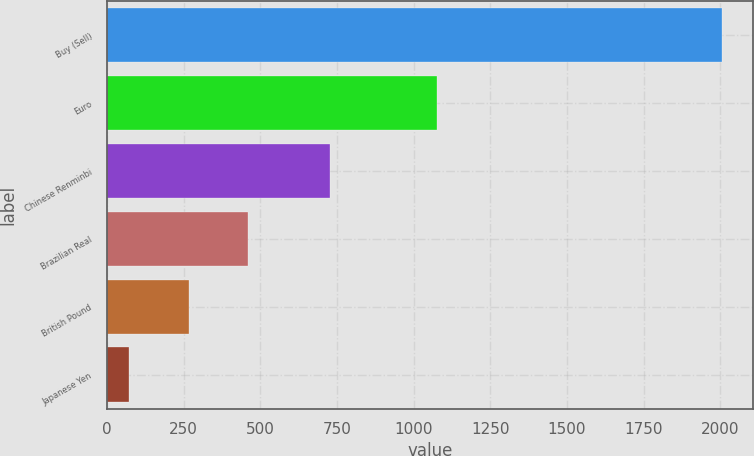Convert chart. <chart><loc_0><loc_0><loc_500><loc_500><bar_chart><fcel>Buy (Sell)<fcel>Euro<fcel>Chinese Renminbi<fcel>Brazilian Real<fcel>British Pound<fcel>Japanese Yen<nl><fcel>2005<fcel>1076<fcel>728<fcel>459.4<fcel>266.2<fcel>73<nl></chart> 